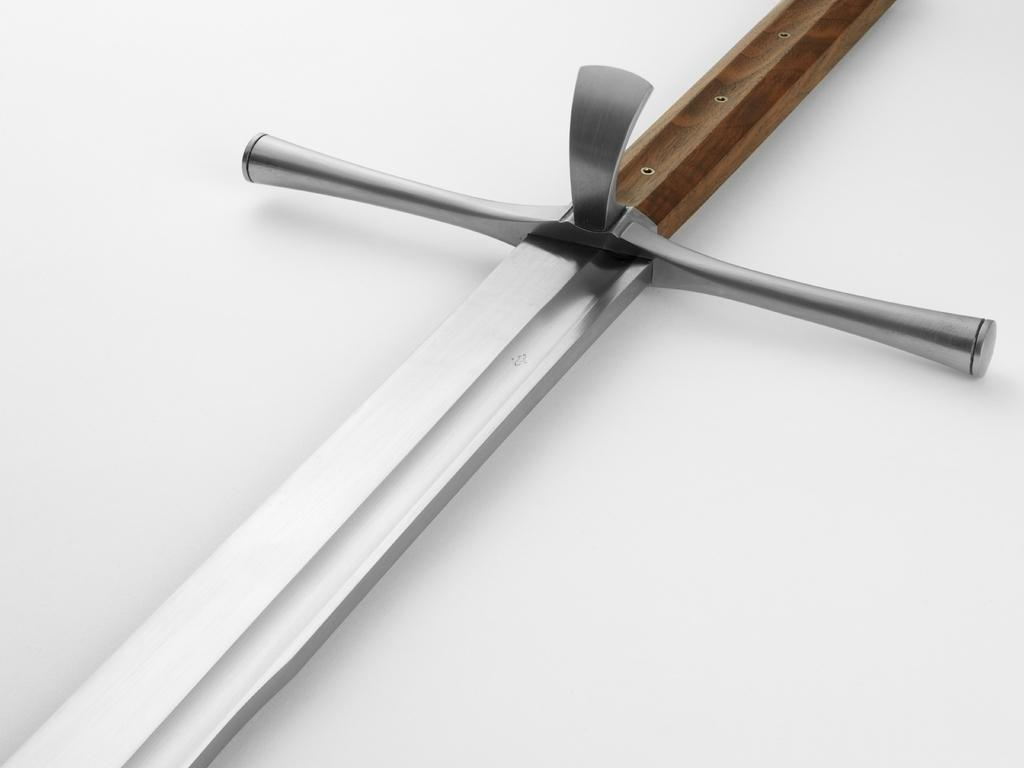What object in the image can be considered a weapon? There is a weapon in the image. What colors can be seen on the weapon? The weapon has brown and silver colors. What is the color of the background in the image? The background of the image is white. What type of nerve can be seen connected to the weapon in the image? There is no nerve connected to the weapon in the image. What type of sponge is being used to clean the weapon in the image? There is no sponge present in the image, and the weapon is not being cleaned. 